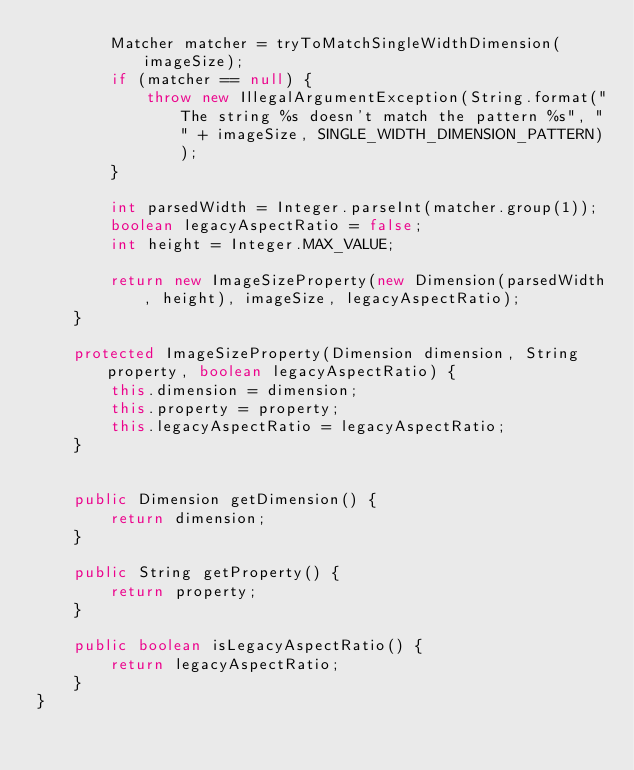<code> <loc_0><loc_0><loc_500><loc_500><_Java_>		Matcher matcher = tryToMatchSingleWidthDimension(imageSize);
		if (matcher == null) {
			throw new IllegalArgumentException(String.format("The string %s doesn't match the pattern %s", "" + imageSize, SINGLE_WIDTH_DIMENSION_PATTERN));
		}

		int parsedWidth = Integer.parseInt(matcher.group(1));
		boolean legacyAspectRatio = false;
		int height = Integer.MAX_VALUE;

		return new ImageSizeProperty(new Dimension(parsedWidth, height), imageSize, legacyAspectRatio);
	}

	protected ImageSizeProperty(Dimension dimension, String property, boolean legacyAspectRatio) {
		this.dimension = dimension;
		this.property = property;
		this.legacyAspectRatio = legacyAspectRatio;
	}


	public Dimension getDimension() {
		return dimension;
	}

	public String getProperty() {
		return property;
	}

	public boolean isLegacyAspectRatio() {
		return legacyAspectRatio;
	}
}
</code> 